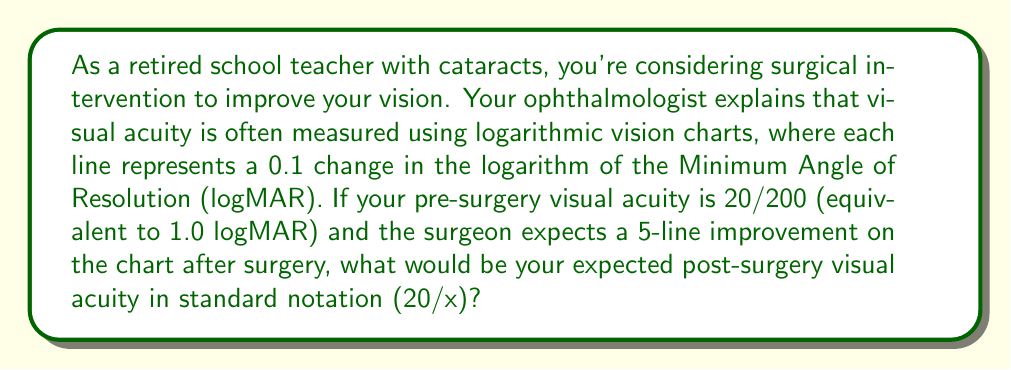Show me your answer to this math problem. To solve this problem, we need to follow these steps:

1. Understand the relationship between logMAR and standard notation:
   - 0.0 logMAR corresponds to 20/20 vision
   - Each 0.1 increase in logMAR represents a doubling of the denominator in standard notation

2. Calculate the expected post-surgery logMAR:
   - Pre-surgery logMAR = 1.0
   - Each line on the chart represents 0.1 logMAR
   - 5-line improvement = 5 * 0.1 = 0.5 logMAR improvement
   - Post-surgery logMAR = 1.0 - 0.5 = 0.5 logMAR

3. Convert 0.5 logMAR to standard notation:
   - 0.0 logMAR = 20/20
   - 0.1 logMAR = 20/25
   - 0.2 logMAR = 20/32
   - 0.3 logMAR = 20/40
   - 0.4 logMAR = 20/50
   - 0.5 logMAR = 20/63 (rounded to the nearest whole number)

The mathematical relationship can be expressed as:

$$ \text{Denominator} = 20 * 10^{\text{logMAR}} $$

For 0.5 logMAR:
$$ \text{Denominator} = 20 * 10^{0.5} \approx 63.2 $$

Rounding to the nearest whole number gives us 63.

Therefore, the expected post-surgery visual acuity in standard notation is 20/63.
Answer: 20/63 